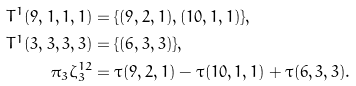Convert formula to latex. <formula><loc_0><loc_0><loc_500><loc_500>T ^ { 1 } ( 9 , 1 , 1 , 1 ) & = \{ ( 9 , 2 , 1 ) , ( 1 0 , 1 , 1 ) \} , \\ T ^ { 1 } ( 3 , 3 , 3 , 3 ) & = \{ ( 6 , 3 , 3 ) \} , \\ \pi _ { 3 } \zeta _ { 3 } ^ { 1 2 } & = \tau ( 9 , 2 , 1 ) - \tau ( 1 0 , 1 , 1 ) + \tau ( 6 , 3 , 3 ) .</formula> 